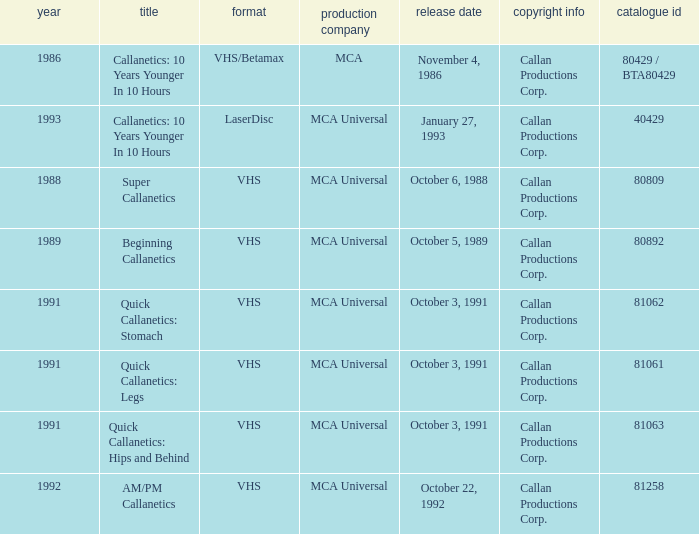Name the studio for catalog number 81063 MCA Universal. Could you parse the entire table as a dict? {'header': ['year', 'title', 'format', 'production company', 'release date', 'copyright info', 'catalogue id'], 'rows': [['1986', 'Callanetics: 10 Years Younger In 10 Hours', 'VHS/Betamax', 'MCA', 'November 4, 1986', 'Callan Productions Corp.', '80429 / BTA80429'], ['1993', 'Callanetics: 10 Years Younger In 10 Hours', 'LaserDisc', 'MCA Universal', 'January 27, 1993', 'Callan Productions Corp.', '40429'], ['1988', 'Super Callanetics', 'VHS', 'MCA Universal', 'October 6, 1988', 'Callan Productions Corp.', '80809'], ['1989', 'Beginning Callanetics', 'VHS', 'MCA Universal', 'October 5, 1989', 'Callan Productions Corp.', '80892'], ['1991', 'Quick Callanetics: Stomach', 'VHS', 'MCA Universal', 'October 3, 1991', 'Callan Productions Corp.', '81062'], ['1991', 'Quick Callanetics: Legs', 'VHS', 'MCA Universal', 'October 3, 1991', 'Callan Productions Corp.', '81061'], ['1991', 'Quick Callanetics: Hips and Behind', 'VHS', 'MCA Universal', 'October 3, 1991', 'Callan Productions Corp.', '81063'], ['1992', 'AM/PM Callanetics', 'VHS', 'MCA Universal', 'October 22, 1992', 'Callan Productions Corp.', '81258']]} 